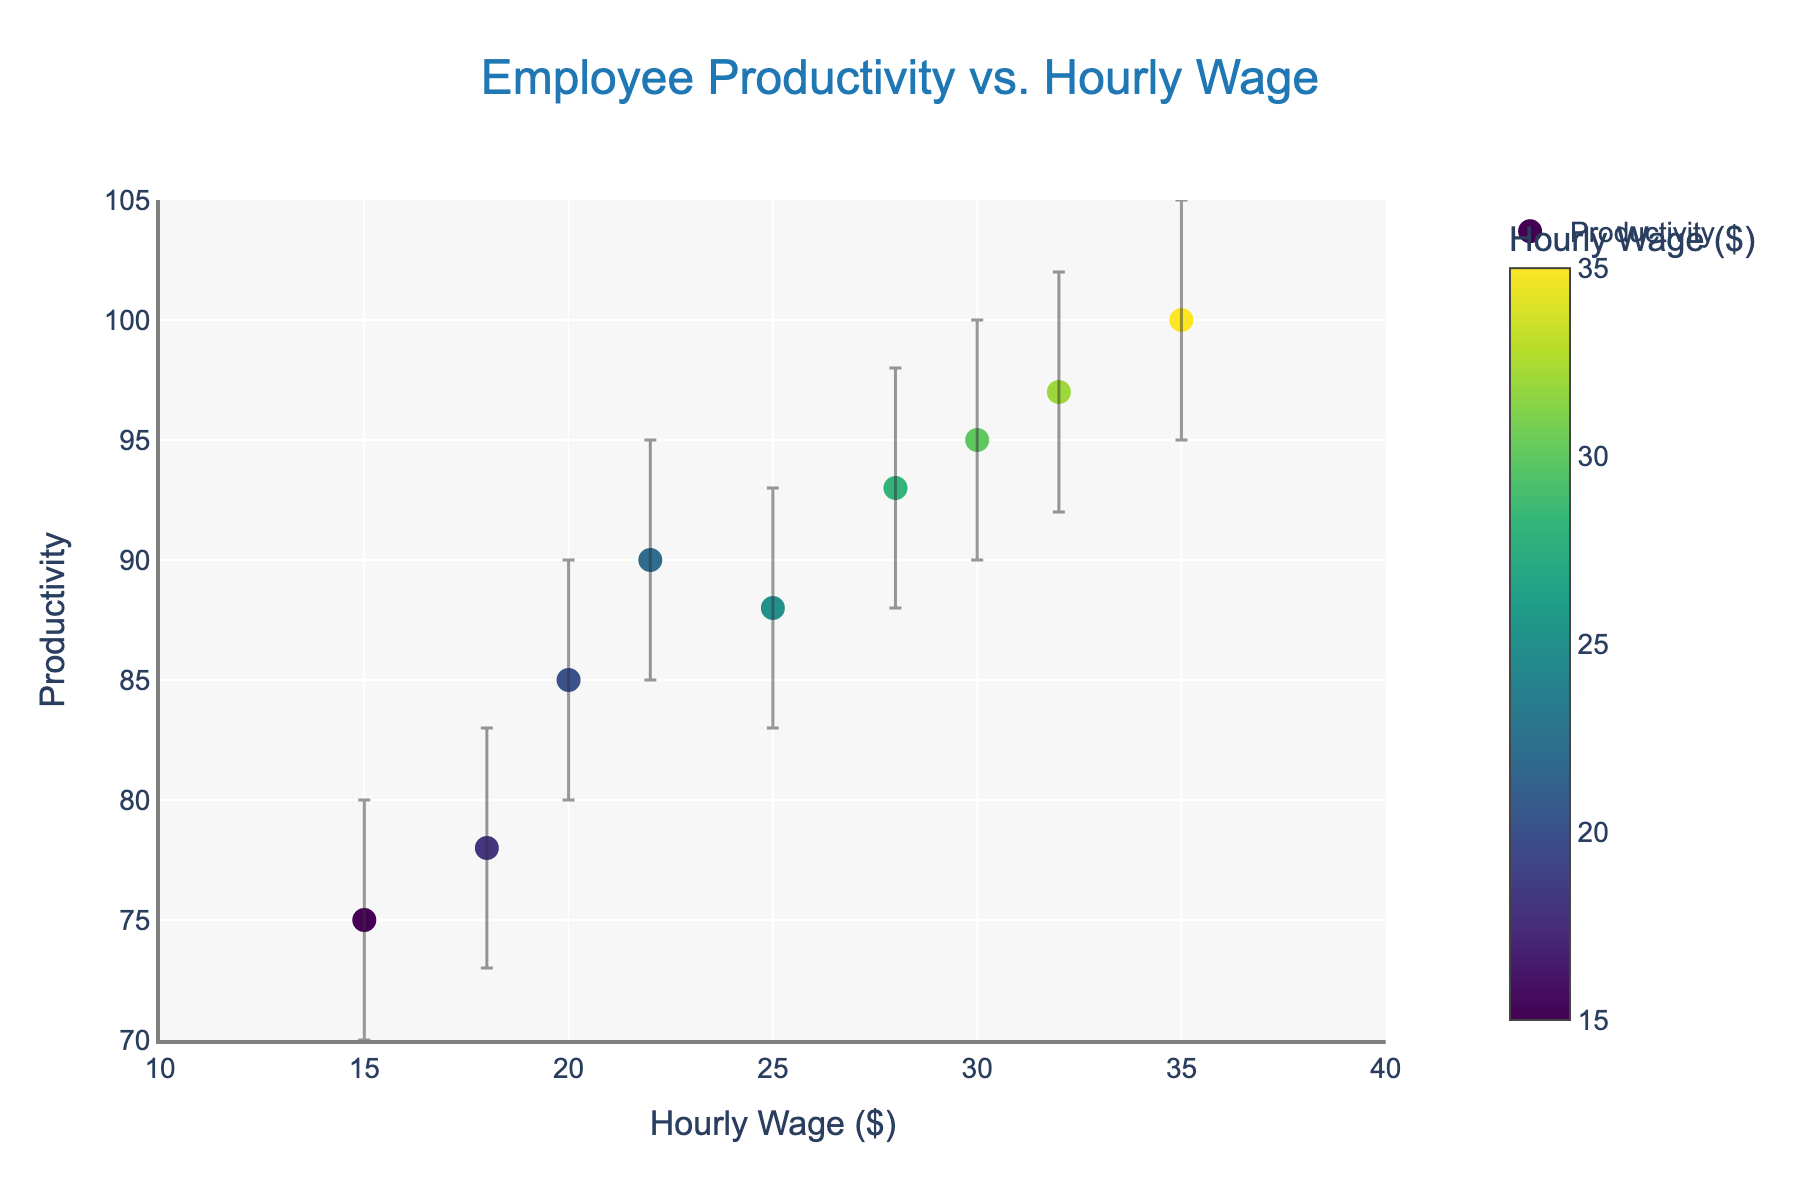What's the title of the plot? The title is located at the top of the plot. It is usually descriptive of the data being visualized.
Answer: Employee Productivity vs. Hourly Wage What's the range of the hourly wages displayed on the x-axis? The x-axis range can be determined by noting the minimum and maximum values shown on the horizontal axis. The x-axis is labeled "Hourly Wage ($)".
Answer: 10 to 40 dollars How many employees are represented in the plot? Each data point in the scatter plot represents one employee, and we can count the number of markers plotted.
Answer: 9 employees Which employee has the highest productivity, and what is their hourly wage? The employee with the highest productivity can be identified by finding the data point with the highest y-value in the plot. The hover text shows the employee's name and corresponding hourly wage.
Answer: Ian, 35 dollars What is the productivity value for Alice? Alice's productivity can be found by locating her data point on the plot, either through the hover text or her position on the y-axis.
Answer: 75 Who has a higher productivity, Eve or Frank? To determine this, compare the y-values for Eve and Frank.
Answer: Frank What is the productivity range for Grace within the confidence interval? The confidence interval for Grace can be determined by looking at her error bars. The lower and upper bounds of the interval provide the range.
Answer: 90 to 100 What is the average productivity of employees earning more than 25 dollars per hour? Calculate the average productivity by adding the productivity values of Grace, Hannah, and Ian (employees earning more than 25 dollars per hour), and then divide by 3. The values are 95, 97, and 100 respectively.
Answer: 97.33 Which employees have overlapping confidence intervals for their productivity? Examine the error bars for each employee and identify which intervals overlap. This requires a close look at the upper and lower error bars for each employee.
Answer: Alice and Bob, Bob and Charlie, David and Eve, Eve and Frank Is there a general trend between hourly wage and productivity, and if yes, what is it? By observing the overall pattern of the scatter plot, we can see if higher hourly wages are associated with higher productivity values. This can be inferred if the data points tend to rise as you move to the right.
Answer: Yes, productivity generally increases with hourly wage 